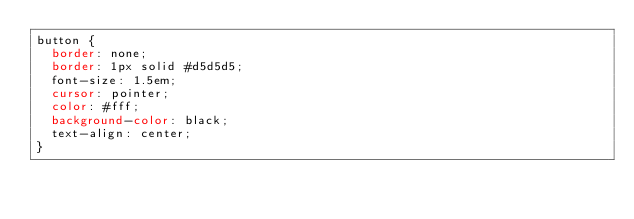<code> <loc_0><loc_0><loc_500><loc_500><_CSS_>button {
  border: none;
  border: 1px solid #d5d5d5;
  font-size: 1.5em;
  cursor: pointer;
  color: #fff;
  background-color: black;
  text-align: center;
}
</code> 